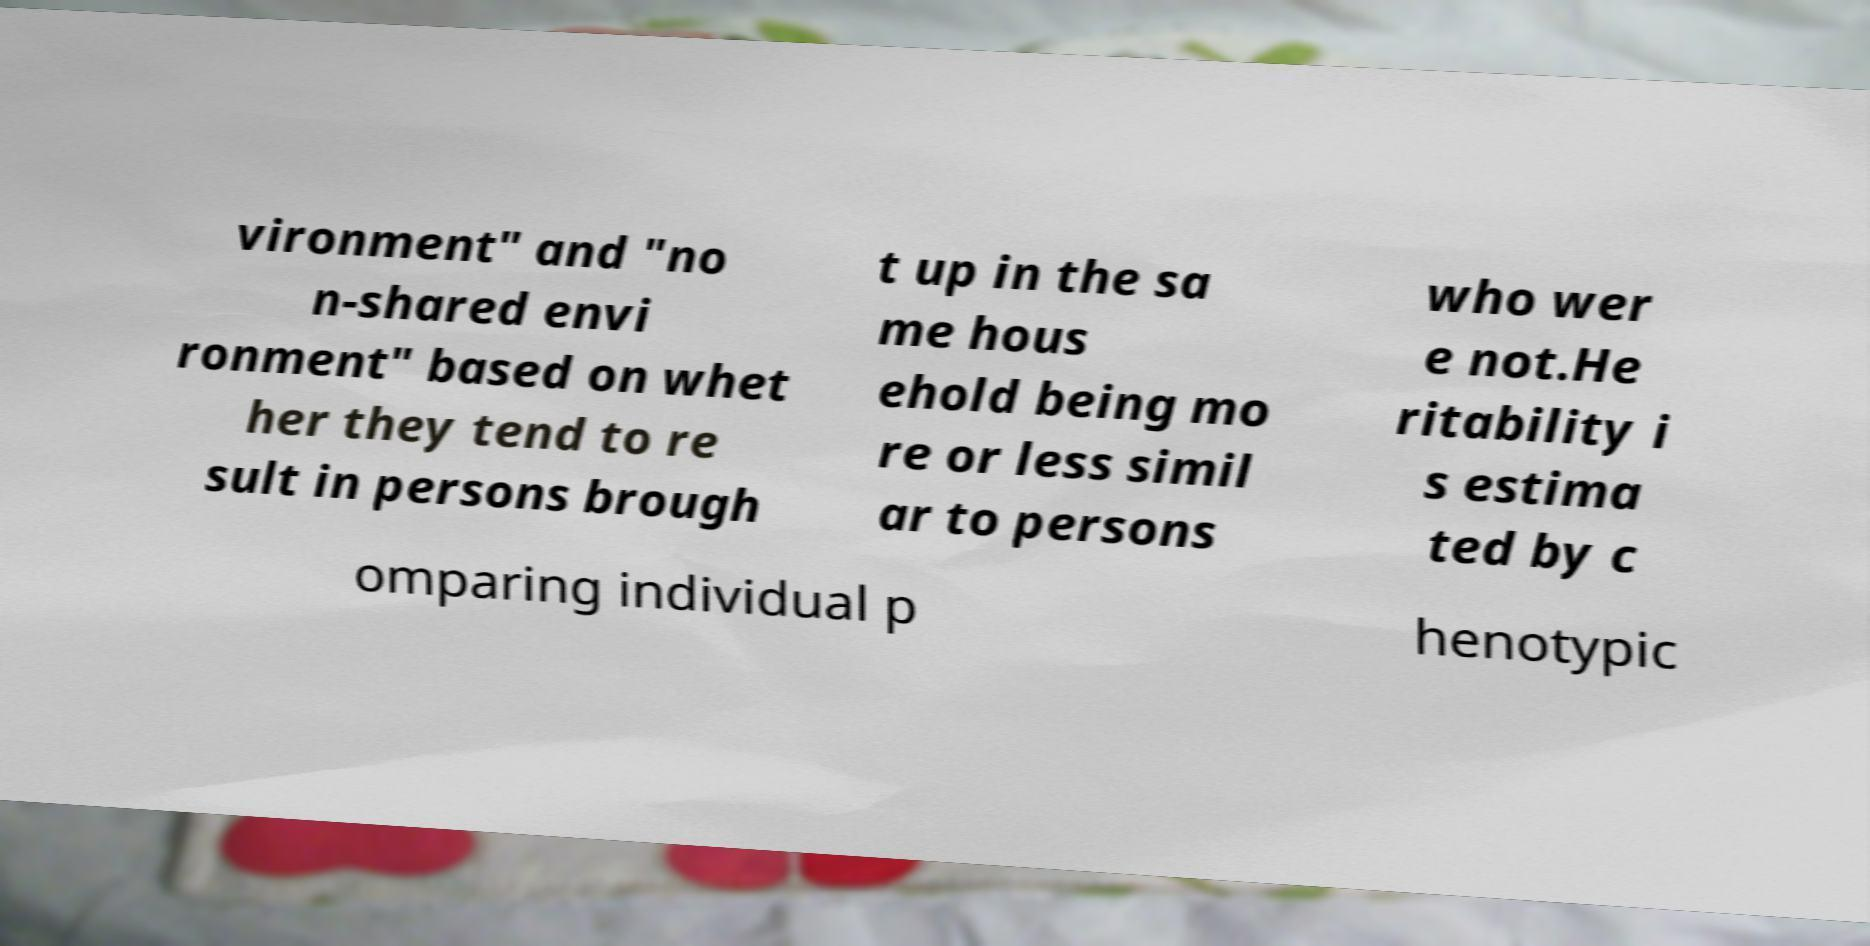Please read and relay the text visible in this image. What does it say? vironment" and "no n-shared envi ronment" based on whet her they tend to re sult in persons brough t up in the sa me hous ehold being mo re or less simil ar to persons who wer e not.He ritability i s estima ted by c omparing individual p henotypic 